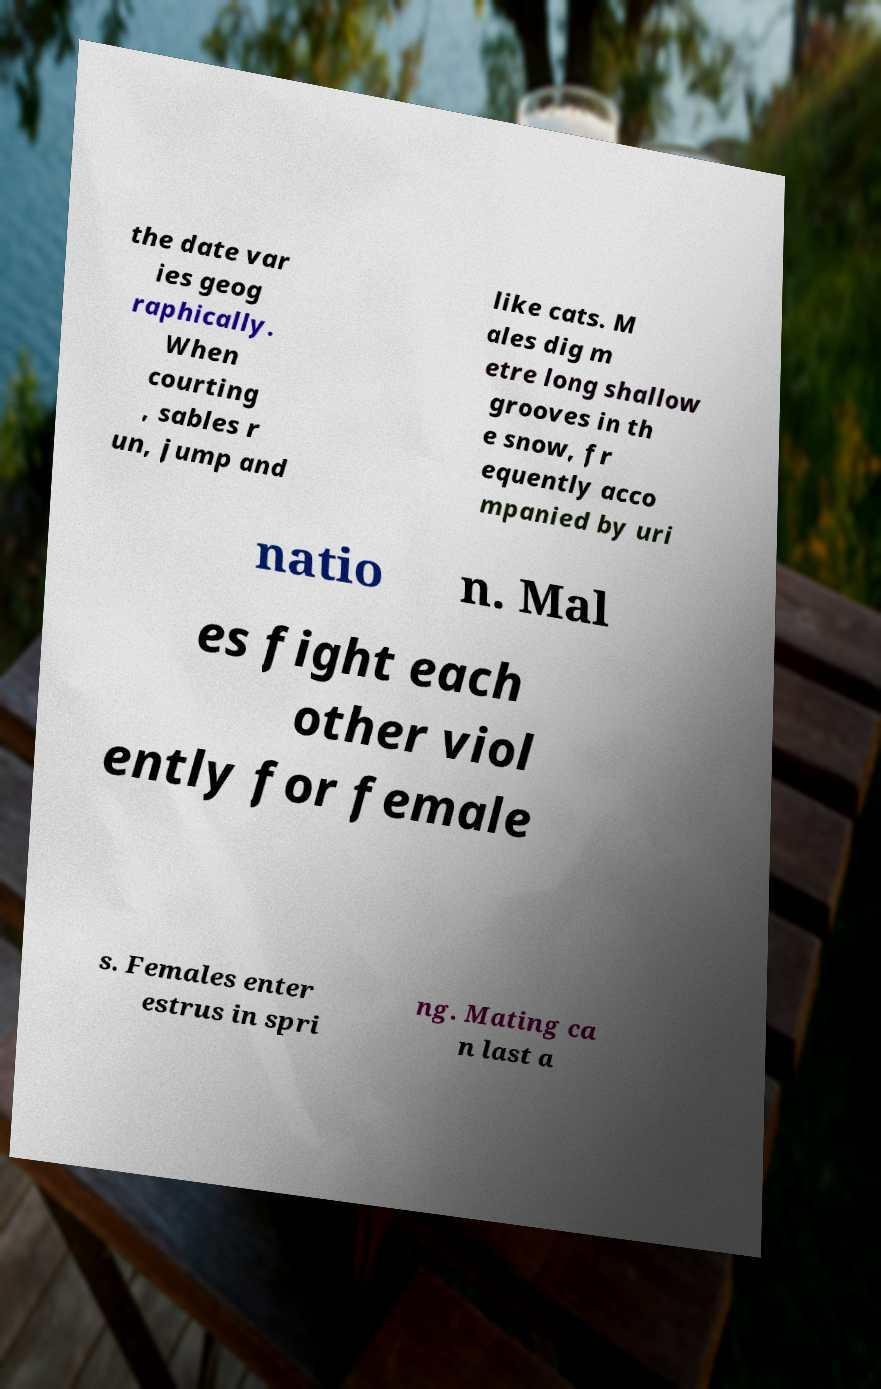Can you accurately transcribe the text from the provided image for me? the date var ies geog raphically. When courting , sables r un, jump and like cats. M ales dig m etre long shallow grooves in th e snow, fr equently acco mpanied by uri natio n. Mal es fight each other viol ently for female s. Females enter estrus in spri ng. Mating ca n last a 